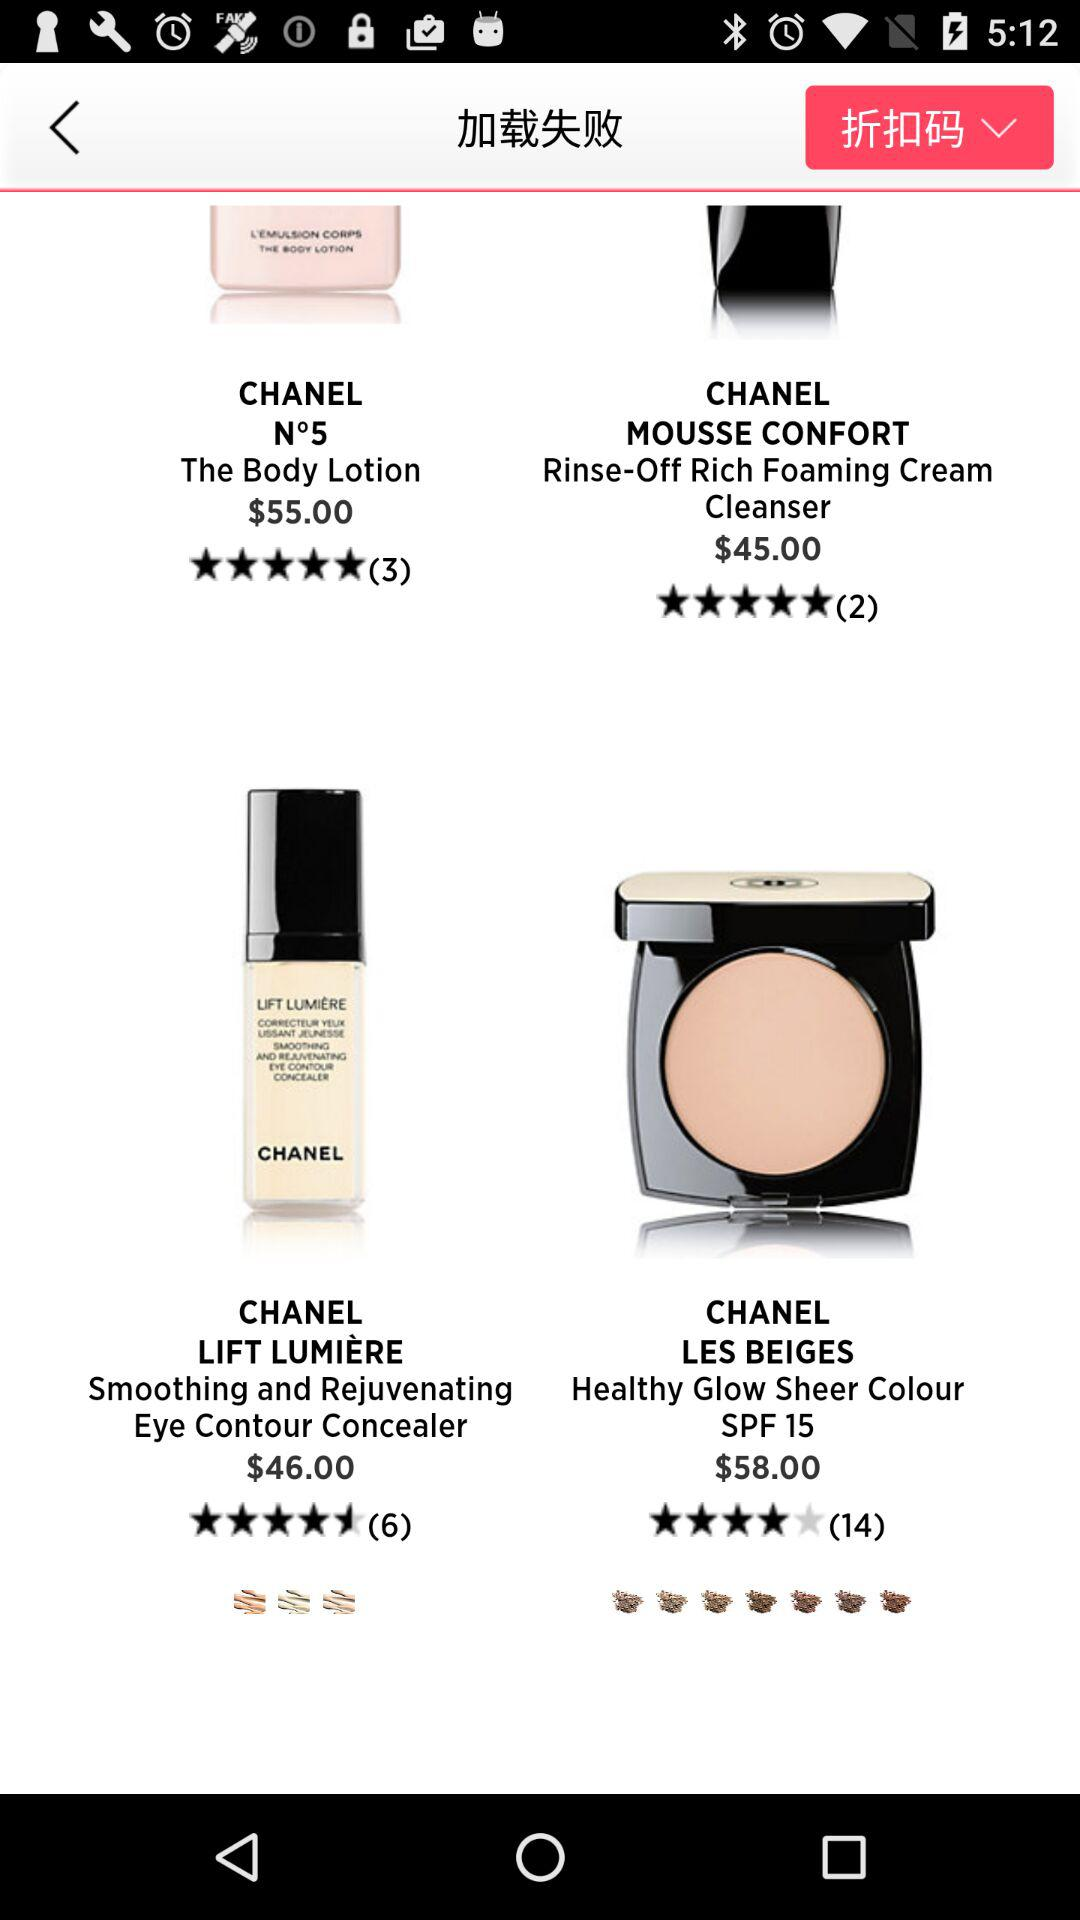How much more expensive is the product with the highest price than the product with the lowest price?
Answer the question using a single word or phrase. $13.00 